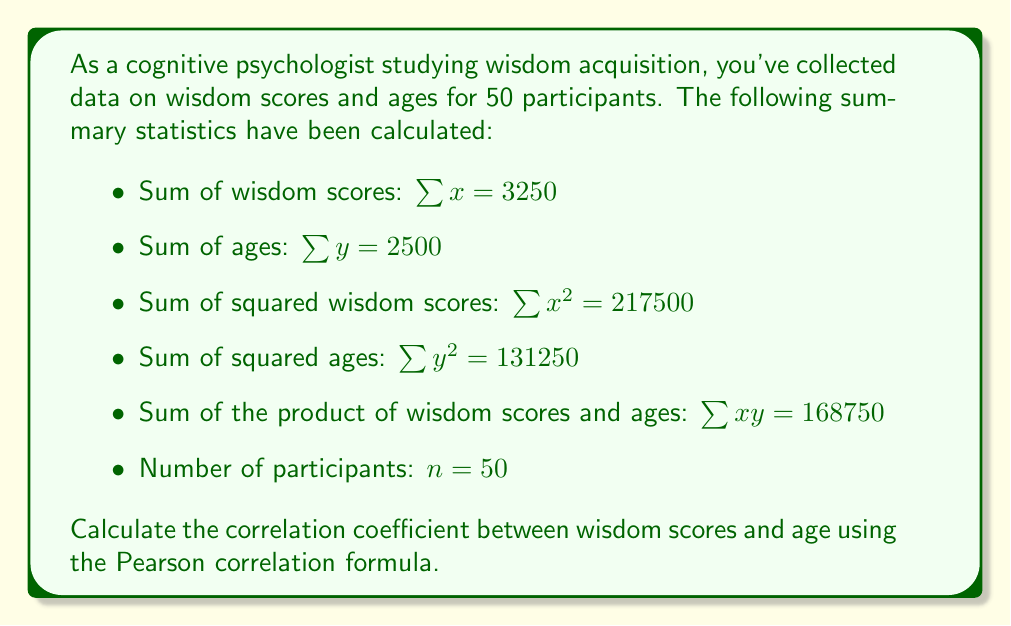Could you help me with this problem? To calculate the correlation coefficient (r) between wisdom scores (x) and age (y), we'll use the Pearson correlation formula:

$$r = \frac{n\sum xy - (\sum x)(\sum y)}{\sqrt{[n\sum x^2 - (\sum x)^2][n\sum y^2 - (\sum y)^2]}}$$

Let's substitute the given values and calculate step by step:

1) Calculate $n\sum xy$:
   $50 \times 168750 = 8437500$

2) Calculate $(\sum x)(\sum y)$:
   $3250 \times 2500 = 8125000$

3) Calculate $n\sum x^2$:
   $50 \times 217500 = 10875000$

4) Calculate $(\sum x)^2$:
   $3250^2 = 10562500$

5) Calculate $n\sum y^2$:
   $50 \times 131250 = 6562500$

6) Calculate $(\sum y)^2$:
   $2500^2 = 6250000$

Now, let's substitute these values into the correlation formula:

$$r = \frac{8437500 - 8125000}{\sqrt{(10875000 - 10562500)(6562500 - 6250000)}}$$

$$r = \frac{312500}{\sqrt{(312500)(312500)}}$$

$$r = \frac{312500}{312500}$$

$$r = 1$$
Answer: $r = 1$ 